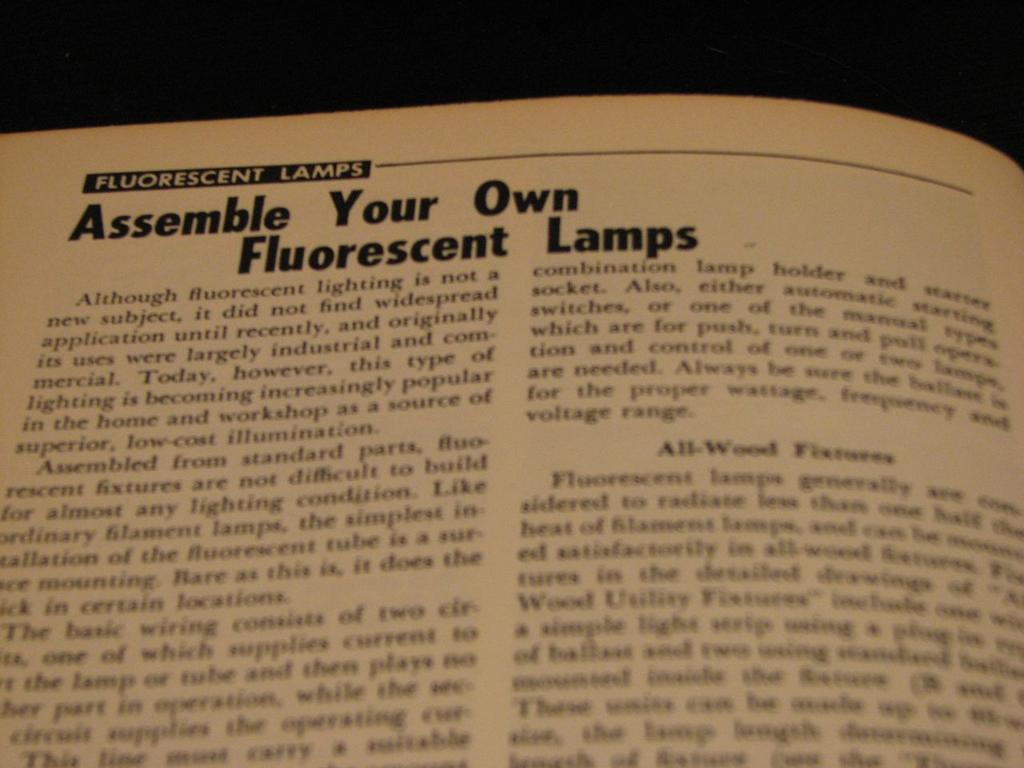What is the title of this chapter?
Provide a succinct answer. Assemble your own fluorescent lamps. 